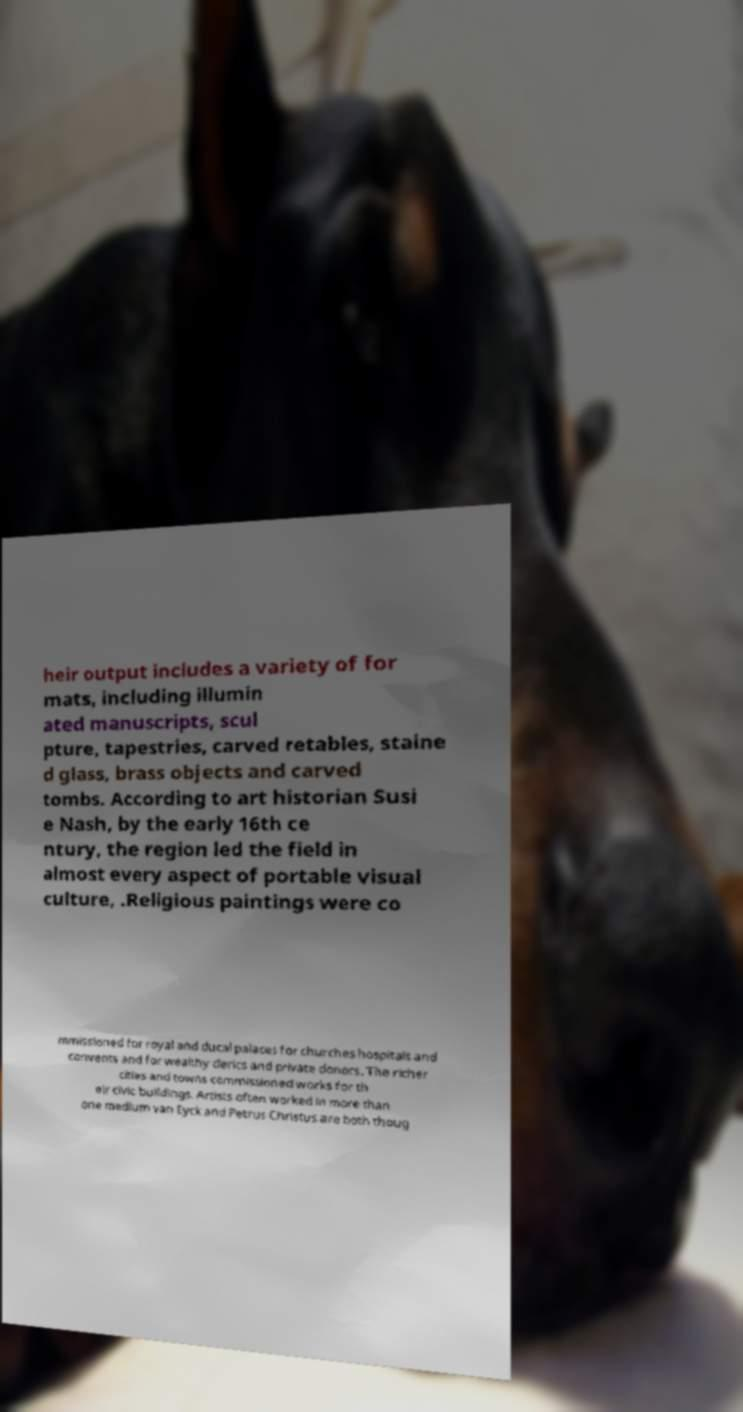Can you read and provide the text displayed in the image?This photo seems to have some interesting text. Can you extract and type it out for me? heir output includes a variety of for mats, including illumin ated manuscripts, scul pture, tapestries, carved retables, staine d glass, brass objects and carved tombs. According to art historian Susi e Nash, by the early 16th ce ntury, the region led the field in almost every aspect of portable visual culture, .Religious paintings were co mmissioned for royal and ducal palaces for churches hospitals and convents and for wealthy clerics and private donors. The richer cities and towns commissioned works for th eir civic buildings. Artists often worked in more than one medium van Eyck and Petrus Christus are both thoug 